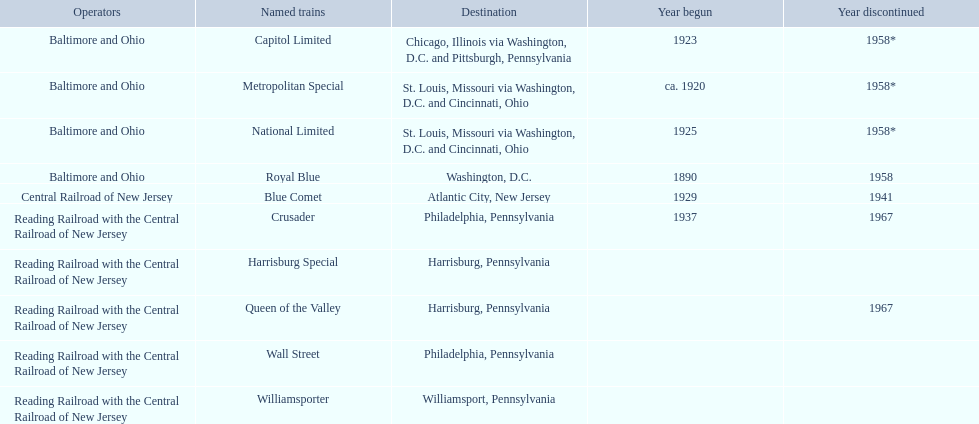What destinations are there? Chicago, Illinois via Washington, D.C. and Pittsburgh, Pennsylvania, St. Louis, Missouri via Washington, D.C. and Cincinnati, Ohio, St. Louis, Missouri via Washington, D.C. and Cincinnati, Ohio, Washington, D.C., Atlantic City, New Jersey, Philadelphia, Pennsylvania, Harrisburg, Pennsylvania, Harrisburg, Pennsylvania, Philadelphia, Pennsylvania, Williamsport, Pennsylvania. Which one is at the top of the list? Chicago, Illinois via Washington, D.C. and Pittsburgh, Pennsylvania. 